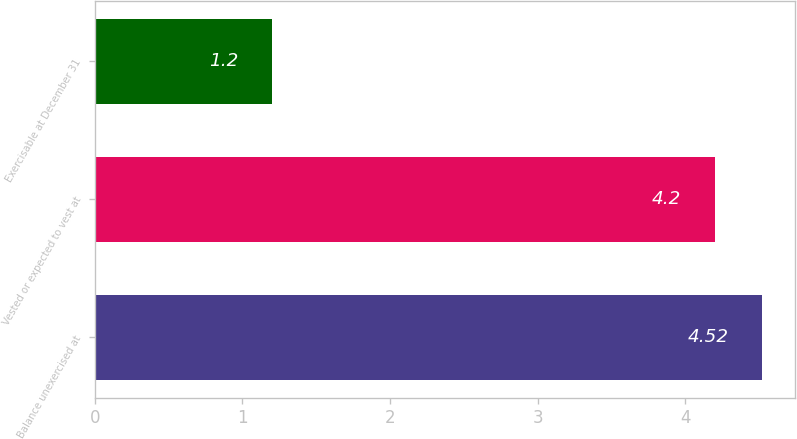<chart> <loc_0><loc_0><loc_500><loc_500><bar_chart><fcel>Balance unexercised at<fcel>Vested or expected to vest at<fcel>Exercisable at December 31<nl><fcel>4.52<fcel>4.2<fcel>1.2<nl></chart> 